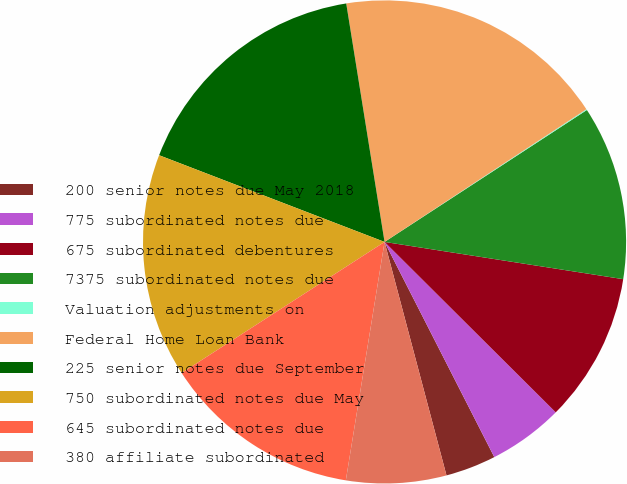Convert chart. <chart><loc_0><loc_0><loc_500><loc_500><pie_chart><fcel>200 senior notes due May 2018<fcel>775 subordinated notes due<fcel>675 subordinated debentures<fcel>7375 subordinated notes due<fcel>Valuation adjustments on<fcel>Federal Home Loan Bank<fcel>225 senior notes due September<fcel>750 subordinated notes due May<fcel>645 subordinated notes due<fcel>380 affiliate subordinated<nl><fcel>3.38%<fcel>5.03%<fcel>10.0%<fcel>11.66%<fcel>0.06%<fcel>18.28%<fcel>16.62%<fcel>14.97%<fcel>13.31%<fcel>6.69%<nl></chart> 